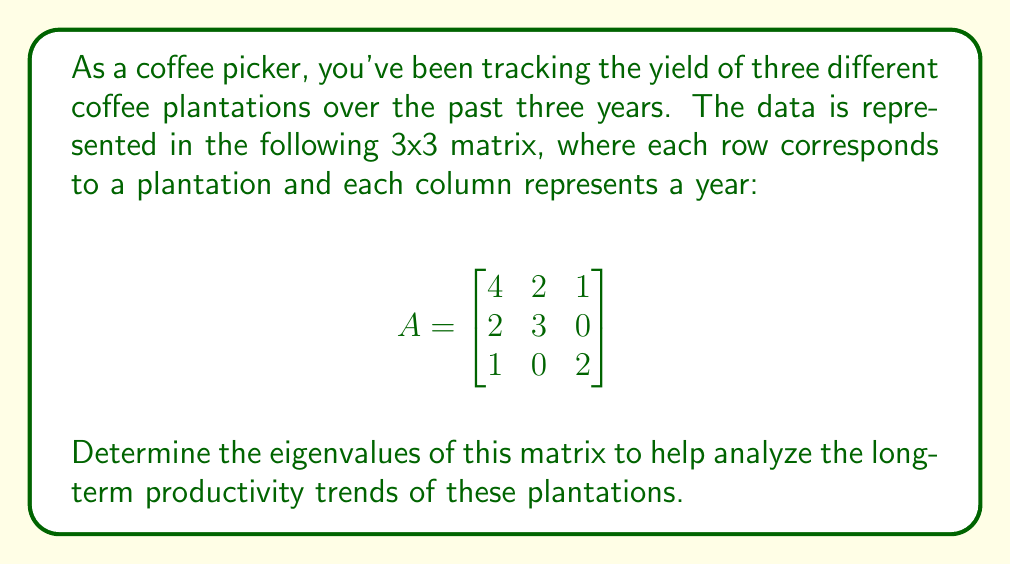Solve this math problem. To find the eigenvalues of matrix A, we need to follow these steps:

1) First, we need to calculate the characteristic polynomial:
   $det(A - \lambda I) = 0$, where $I$ is the 3x3 identity matrix.

2) Expand the determinant:
   $$det\begin{bmatrix}
   4-\lambda & 2 & 1 \\
   2 & 3-\lambda & 0 \\
   1 & 0 & 2-\lambda
   \end{bmatrix} = 0$$

3) Calculate the determinant:
   $(4-\lambda)[(3-\lambda)(2-\lambda) - 0] - 2[2(2-\lambda) - 1(0)] + 1[2(0) - 1(3-\lambda)] = 0$

4) Simplify:
   $(4-\lambda)(6-5\lambda+\lambda^2) - 4(2-\lambda) + (3-\lambda) = 0$
   $24-20\lambda+4\lambda^2-6\lambda+5\lambda^2-\lambda^3 - 8+4\lambda + 3-\lambda = 0$

5) Combine like terms:
   $-\lambda^3 + 9\lambda^2 - 23\lambda + 19 = 0$

6) This is the characteristic polynomial. To find the eigenvalues, we need to find the roots of this polynomial.

7) By factoring or using the cubic formula (which is complex), we can find that the roots are:
   $\lambda_1 = 1$, $\lambda_2 = 3$, $\lambda_3 = 5$

These are the eigenvalues of the matrix A.
Answer: $\lambda_1 = 1$, $\lambda_2 = 3$, $\lambda_3 = 5$ 